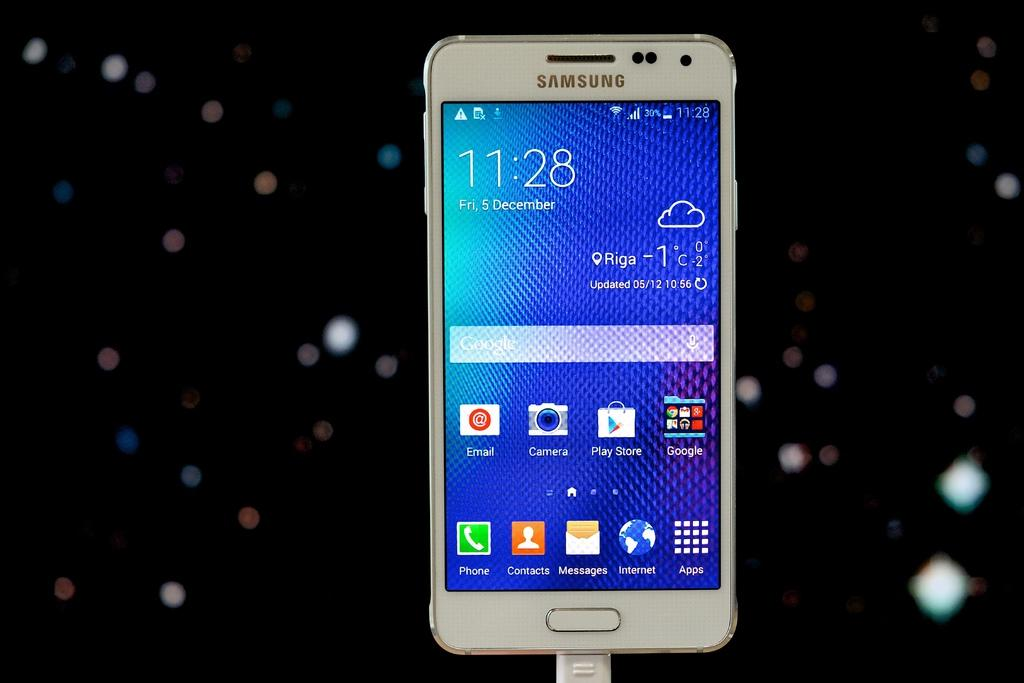<image>
Create a compact narrative representing the image presented. A Samsung smart phone open to its home page. 